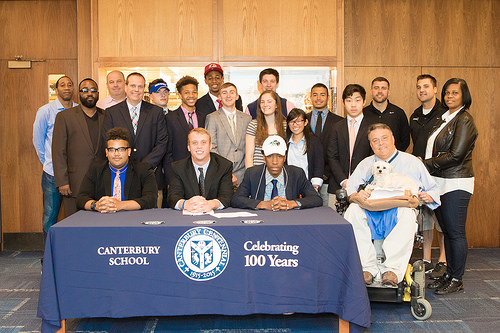<image>
Is there a person above the table? No. The person is not positioned above the table. The vertical arrangement shows a different relationship. 